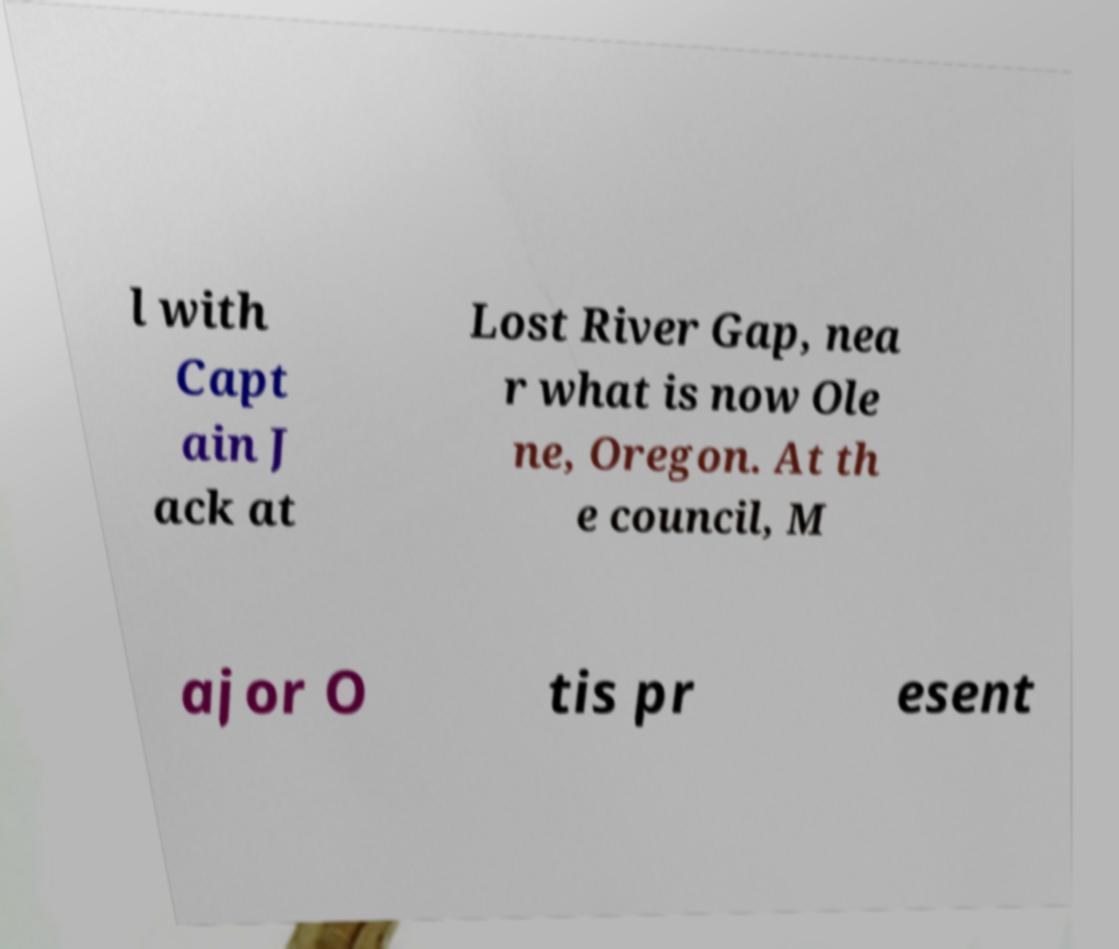Can you read and provide the text displayed in the image?This photo seems to have some interesting text. Can you extract and type it out for me? l with Capt ain J ack at Lost River Gap, nea r what is now Ole ne, Oregon. At th e council, M ajor O tis pr esent 